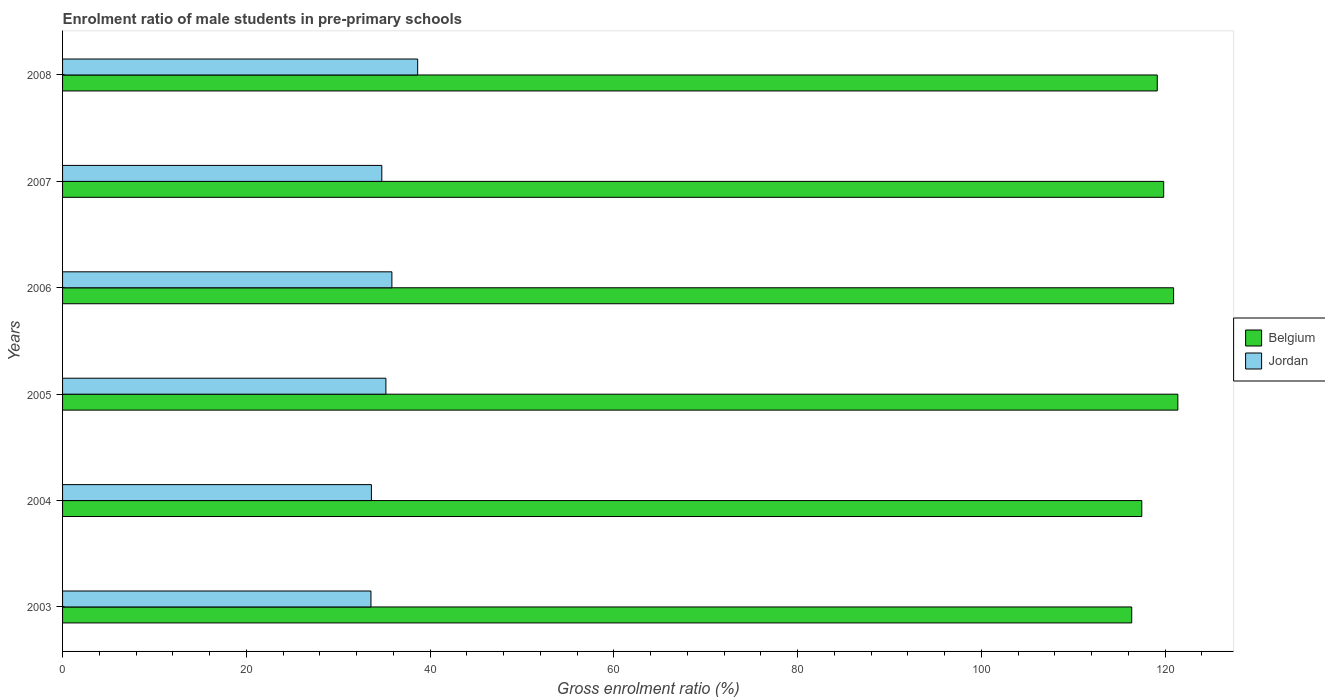How many different coloured bars are there?
Your answer should be very brief. 2. How many groups of bars are there?
Ensure brevity in your answer.  6. Are the number of bars per tick equal to the number of legend labels?
Your answer should be compact. Yes. Are the number of bars on each tick of the Y-axis equal?
Provide a short and direct response. Yes. How many bars are there on the 4th tick from the top?
Provide a short and direct response. 2. How many bars are there on the 3rd tick from the bottom?
Offer a very short reply. 2. What is the enrolment ratio of male students in pre-primary schools in Belgium in 2008?
Offer a very short reply. 119.15. Across all years, what is the maximum enrolment ratio of male students in pre-primary schools in Belgium?
Provide a succinct answer. 121.39. Across all years, what is the minimum enrolment ratio of male students in pre-primary schools in Belgium?
Offer a terse response. 116.37. In which year was the enrolment ratio of male students in pre-primary schools in Jordan maximum?
Offer a terse response. 2008. What is the total enrolment ratio of male students in pre-primary schools in Belgium in the graph?
Offer a very short reply. 715.15. What is the difference between the enrolment ratio of male students in pre-primary schools in Belgium in 2005 and that in 2007?
Provide a succinct answer. 1.54. What is the difference between the enrolment ratio of male students in pre-primary schools in Belgium in 2006 and the enrolment ratio of male students in pre-primary schools in Jordan in 2008?
Offer a terse response. 82.28. What is the average enrolment ratio of male students in pre-primary schools in Belgium per year?
Your answer should be compact. 119.19. In the year 2008, what is the difference between the enrolment ratio of male students in pre-primary schools in Belgium and enrolment ratio of male students in pre-primary schools in Jordan?
Keep it short and to the point. 80.5. In how many years, is the enrolment ratio of male students in pre-primary schools in Jordan greater than 20 %?
Offer a very short reply. 6. What is the ratio of the enrolment ratio of male students in pre-primary schools in Jordan in 2004 to that in 2006?
Offer a terse response. 0.94. Is the enrolment ratio of male students in pre-primary schools in Jordan in 2004 less than that in 2006?
Make the answer very short. Yes. Is the difference between the enrolment ratio of male students in pre-primary schools in Belgium in 2004 and 2007 greater than the difference between the enrolment ratio of male students in pre-primary schools in Jordan in 2004 and 2007?
Give a very brief answer. No. What is the difference between the highest and the second highest enrolment ratio of male students in pre-primary schools in Belgium?
Keep it short and to the point. 0.46. What is the difference between the highest and the lowest enrolment ratio of male students in pre-primary schools in Jordan?
Make the answer very short. 5.09. Is the sum of the enrolment ratio of male students in pre-primary schools in Jordan in 2004 and 2008 greater than the maximum enrolment ratio of male students in pre-primary schools in Belgium across all years?
Your answer should be compact. No. What does the 1st bar from the top in 2003 represents?
Your answer should be very brief. Jordan. What does the 1st bar from the bottom in 2004 represents?
Provide a succinct answer. Belgium. How many bars are there?
Provide a succinct answer. 12. Are all the bars in the graph horizontal?
Your answer should be very brief. Yes. Are the values on the major ticks of X-axis written in scientific E-notation?
Your answer should be compact. No. Where does the legend appear in the graph?
Make the answer very short. Center right. What is the title of the graph?
Your response must be concise. Enrolment ratio of male students in pre-primary schools. What is the label or title of the X-axis?
Provide a succinct answer. Gross enrolment ratio (%). What is the Gross enrolment ratio (%) of Belgium in 2003?
Give a very brief answer. 116.37. What is the Gross enrolment ratio (%) of Jordan in 2003?
Make the answer very short. 33.57. What is the Gross enrolment ratio (%) in Belgium in 2004?
Keep it short and to the point. 117.47. What is the Gross enrolment ratio (%) of Jordan in 2004?
Offer a terse response. 33.61. What is the Gross enrolment ratio (%) in Belgium in 2005?
Give a very brief answer. 121.39. What is the Gross enrolment ratio (%) of Jordan in 2005?
Make the answer very short. 35.19. What is the Gross enrolment ratio (%) of Belgium in 2006?
Provide a succinct answer. 120.93. What is the Gross enrolment ratio (%) in Jordan in 2006?
Provide a short and direct response. 35.84. What is the Gross enrolment ratio (%) in Belgium in 2007?
Ensure brevity in your answer.  119.85. What is the Gross enrolment ratio (%) of Jordan in 2007?
Provide a short and direct response. 34.75. What is the Gross enrolment ratio (%) of Belgium in 2008?
Offer a very short reply. 119.15. What is the Gross enrolment ratio (%) in Jordan in 2008?
Offer a very short reply. 38.65. Across all years, what is the maximum Gross enrolment ratio (%) of Belgium?
Offer a very short reply. 121.39. Across all years, what is the maximum Gross enrolment ratio (%) of Jordan?
Offer a terse response. 38.65. Across all years, what is the minimum Gross enrolment ratio (%) in Belgium?
Your response must be concise. 116.37. Across all years, what is the minimum Gross enrolment ratio (%) of Jordan?
Offer a very short reply. 33.57. What is the total Gross enrolment ratio (%) of Belgium in the graph?
Your answer should be compact. 715.15. What is the total Gross enrolment ratio (%) in Jordan in the graph?
Your answer should be very brief. 211.61. What is the difference between the Gross enrolment ratio (%) in Belgium in 2003 and that in 2004?
Your answer should be very brief. -1.1. What is the difference between the Gross enrolment ratio (%) of Jordan in 2003 and that in 2004?
Your answer should be compact. -0.05. What is the difference between the Gross enrolment ratio (%) of Belgium in 2003 and that in 2005?
Offer a terse response. -5.02. What is the difference between the Gross enrolment ratio (%) in Jordan in 2003 and that in 2005?
Provide a succinct answer. -1.63. What is the difference between the Gross enrolment ratio (%) of Belgium in 2003 and that in 2006?
Keep it short and to the point. -4.56. What is the difference between the Gross enrolment ratio (%) of Jordan in 2003 and that in 2006?
Offer a very short reply. -2.28. What is the difference between the Gross enrolment ratio (%) of Belgium in 2003 and that in 2007?
Your answer should be very brief. -3.48. What is the difference between the Gross enrolment ratio (%) of Jordan in 2003 and that in 2007?
Ensure brevity in your answer.  -1.18. What is the difference between the Gross enrolment ratio (%) in Belgium in 2003 and that in 2008?
Ensure brevity in your answer.  -2.78. What is the difference between the Gross enrolment ratio (%) of Jordan in 2003 and that in 2008?
Give a very brief answer. -5.09. What is the difference between the Gross enrolment ratio (%) of Belgium in 2004 and that in 2005?
Your answer should be very brief. -3.92. What is the difference between the Gross enrolment ratio (%) of Jordan in 2004 and that in 2005?
Your response must be concise. -1.58. What is the difference between the Gross enrolment ratio (%) of Belgium in 2004 and that in 2006?
Ensure brevity in your answer.  -3.46. What is the difference between the Gross enrolment ratio (%) in Jordan in 2004 and that in 2006?
Give a very brief answer. -2.23. What is the difference between the Gross enrolment ratio (%) of Belgium in 2004 and that in 2007?
Offer a very short reply. -2.38. What is the difference between the Gross enrolment ratio (%) of Jordan in 2004 and that in 2007?
Provide a short and direct response. -1.13. What is the difference between the Gross enrolment ratio (%) of Belgium in 2004 and that in 2008?
Keep it short and to the point. -1.68. What is the difference between the Gross enrolment ratio (%) in Jordan in 2004 and that in 2008?
Keep it short and to the point. -5.04. What is the difference between the Gross enrolment ratio (%) in Belgium in 2005 and that in 2006?
Offer a very short reply. 0.46. What is the difference between the Gross enrolment ratio (%) of Jordan in 2005 and that in 2006?
Keep it short and to the point. -0.65. What is the difference between the Gross enrolment ratio (%) in Belgium in 2005 and that in 2007?
Provide a succinct answer. 1.54. What is the difference between the Gross enrolment ratio (%) in Jordan in 2005 and that in 2007?
Your answer should be very brief. 0.45. What is the difference between the Gross enrolment ratio (%) of Belgium in 2005 and that in 2008?
Make the answer very short. 2.24. What is the difference between the Gross enrolment ratio (%) of Jordan in 2005 and that in 2008?
Provide a succinct answer. -3.46. What is the difference between the Gross enrolment ratio (%) of Belgium in 2006 and that in 2007?
Ensure brevity in your answer.  1.08. What is the difference between the Gross enrolment ratio (%) in Jordan in 2006 and that in 2007?
Your response must be concise. 1.1. What is the difference between the Gross enrolment ratio (%) in Belgium in 2006 and that in 2008?
Offer a very short reply. 1.78. What is the difference between the Gross enrolment ratio (%) of Jordan in 2006 and that in 2008?
Give a very brief answer. -2.81. What is the difference between the Gross enrolment ratio (%) of Belgium in 2007 and that in 2008?
Offer a terse response. 0.7. What is the difference between the Gross enrolment ratio (%) of Jordan in 2007 and that in 2008?
Keep it short and to the point. -3.9. What is the difference between the Gross enrolment ratio (%) of Belgium in 2003 and the Gross enrolment ratio (%) of Jordan in 2004?
Offer a terse response. 82.76. What is the difference between the Gross enrolment ratio (%) in Belgium in 2003 and the Gross enrolment ratio (%) in Jordan in 2005?
Make the answer very short. 81.18. What is the difference between the Gross enrolment ratio (%) of Belgium in 2003 and the Gross enrolment ratio (%) of Jordan in 2006?
Make the answer very short. 80.53. What is the difference between the Gross enrolment ratio (%) of Belgium in 2003 and the Gross enrolment ratio (%) of Jordan in 2007?
Your response must be concise. 81.62. What is the difference between the Gross enrolment ratio (%) of Belgium in 2003 and the Gross enrolment ratio (%) of Jordan in 2008?
Your response must be concise. 77.72. What is the difference between the Gross enrolment ratio (%) of Belgium in 2004 and the Gross enrolment ratio (%) of Jordan in 2005?
Provide a succinct answer. 82.27. What is the difference between the Gross enrolment ratio (%) in Belgium in 2004 and the Gross enrolment ratio (%) in Jordan in 2006?
Ensure brevity in your answer.  81.62. What is the difference between the Gross enrolment ratio (%) in Belgium in 2004 and the Gross enrolment ratio (%) in Jordan in 2007?
Provide a short and direct response. 82.72. What is the difference between the Gross enrolment ratio (%) in Belgium in 2004 and the Gross enrolment ratio (%) in Jordan in 2008?
Offer a terse response. 78.81. What is the difference between the Gross enrolment ratio (%) in Belgium in 2005 and the Gross enrolment ratio (%) in Jordan in 2006?
Give a very brief answer. 85.54. What is the difference between the Gross enrolment ratio (%) in Belgium in 2005 and the Gross enrolment ratio (%) in Jordan in 2007?
Ensure brevity in your answer.  86.64. What is the difference between the Gross enrolment ratio (%) of Belgium in 2005 and the Gross enrolment ratio (%) of Jordan in 2008?
Keep it short and to the point. 82.74. What is the difference between the Gross enrolment ratio (%) in Belgium in 2006 and the Gross enrolment ratio (%) in Jordan in 2007?
Offer a very short reply. 86.18. What is the difference between the Gross enrolment ratio (%) in Belgium in 2006 and the Gross enrolment ratio (%) in Jordan in 2008?
Your answer should be very brief. 82.28. What is the difference between the Gross enrolment ratio (%) of Belgium in 2007 and the Gross enrolment ratio (%) of Jordan in 2008?
Your answer should be very brief. 81.2. What is the average Gross enrolment ratio (%) of Belgium per year?
Provide a short and direct response. 119.19. What is the average Gross enrolment ratio (%) in Jordan per year?
Your answer should be very brief. 35.27. In the year 2003, what is the difference between the Gross enrolment ratio (%) in Belgium and Gross enrolment ratio (%) in Jordan?
Your response must be concise. 82.8. In the year 2004, what is the difference between the Gross enrolment ratio (%) in Belgium and Gross enrolment ratio (%) in Jordan?
Offer a terse response. 83.85. In the year 2005, what is the difference between the Gross enrolment ratio (%) of Belgium and Gross enrolment ratio (%) of Jordan?
Ensure brevity in your answer.  86.2. In the year 2006, what is the difference between the Gross enrolment ratio (%) in Belgium and Gross enrolment ratio (%) in Jordan?
Provide a succinct answer. 85.08. In the year 2007, what is the difference between the Gross enrolment ratio (%) in Belgium and Gross enrolment ratio (%) in Jordan?
Your response must be concise. 85.1. In the year 2008, what is the difference between the Gross enrolment ratio (%) in Belgium and Gross enrolment ratio (%) in Jordan?
Your answer should be very brief. 80.5. What is the ratio of the Gross enrolment ratio (%) in Belgium in 2003 to that in 2004?
Offer a terse response. 0.99. What is the ratio of the Gross enrolment ratio (%) of Belgium in 2003 to that in 2005?
Provide a succinct answer. 0.96. What is the ratio of the Gross enrolment ratio (%) of Jordan in 2003 to that in 2005?
Your answer should be compact. 0.95. What is the ratio of the Gross enrolment ratio (%) in Belgium in 2003 to that in 2006?
Provide a short and direct response. 0.96. What is the ratio of the Gross enrolment ratio (%) of Jordan in 2003 to that in 2006?
Keep it short and to the point. 0.94. What is the ratio of the Gross enrolment ratio (%) of Belgium in 2003 to that in 2007?
Give a very brief answer. 0.97. What is the ratio of the Gross enrolment ratio (%) of Belgium in 2003 to that in 2008?
Offer a very short reply. 0.98. What is the ratio of the Gross enrolment ratio (%) in Jordan in 2003 to that in 2008?
Your answer should be very brief. 0.87. What is the ratio of the Gross enrolment ratio (%) in Belgium in 2004 to that in 2005?
Give a very brief answer. 0.97. What is the ratio of the Gross enrolment ratio (%) in Jordan in 2004 to that in 2005?
Your answer should be compact. 0.96. What is the ratio of the Gross enrolment ratio (%) in Belgium in 2004 to that in 2006?
Your answer should be compact. 0.97. What is the ratio of the Gross enrolment ratio (%) in Jordan in 2004 to that in 2006?
Ensure brevity in your answer.  0.94. What is the ratio of the Gross enrolment ratio (%) in Belgium in 2004 to that in 2007?
Keep it short and to the point. 0.98. What is the ratio of the Gross enrolment ratio (%) of Jordan in 2004 to that in 2007?
Provide a succinct answer. 0.97. What is the ratio of the Gross enrolment ratio (%) of Belgium in 2004 to that in 2008?
Your answer should be very brief. 0.99. What is the ratio of the Gross enrolment ratio (%) in Jordan in 2004 to that in 2008?
Your answer should be compact. 0.87. What is the ratio of the Gross enrolment ratio (%) of Jordan in 2005 to that in 2006?
Your response must be concise. 0.98. What is the ratio of the Gross enrolment ratio (%) in Belgium in 2005 to that in 2007?
Ensure brevity in your answer.  1.01. What is the ratio of the Gross enrolment ratio (%) of Jordan in 2005 to that in 2007?
Keep it short and to the point. 1.01. What is the ratio of the Gross enrolment ratio (%) of Belgium in 2005 to that in 2008?
Your response must be concise. 1.02. What is the ratio of the Gross enrolment ratio (%) in Jordan in 2005 to that in 2008?
Ensure brevity in your answer.  0.91. What is the ratio of the Gross enrolment ratio (%) of Jordan in 2006 to that in 2007?
Give a very brief answer. 1.03. What is the ratio of the Gross enrolment ratio (%) of Belgium in 2006 to that in 2008?
Your answer should be compact. 1.01. What is the ratio of the Gross enrolment ratio (%) in Jordan in 2006 to that in 2008?
Ensure brevity in your answer.  0.93. What is the ratio of the Gross enrolment ratio (%) of Belgium in 2007 to that in 2008?
Your answer should be compact. 1.01. What is the ratio of the Gross enrolment ratio (%) of Jordan in 2007 to that in 2008?
Offer a terse response. 0.9. What is the difference between the highest and the second highest Gross enrolment ratio (%) of Belgium?
Offer a very short reply. 0.46. What is the difference between the highest and the second highest Gross enrolment ratio (%) in Jordan?
Make the answer very short. 2.81. What is the difference between the highest and the lowest Gross enrolment ratio (%) in Belgium?
Offer a terse response. 5.02. What is the difference between the highest and the lowest Gross enrolment ratio (%) of Jordan?
Give a very brief answer. 5.09. 